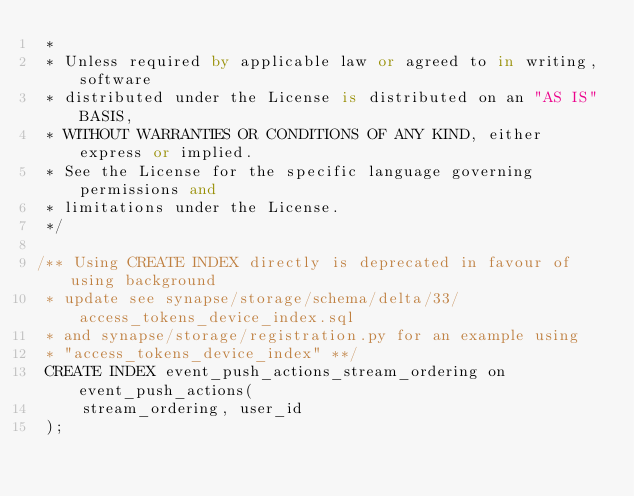<code> <loc_0><loc_0><loc_500><loc_500><_SQL_> *
 * Unless required by applicable law or agreed to in writing, software
 * distributed under the License is distributed on an "AS IS" BASIS,
 * WITHOUT WARRANTIES OR CONDITIONS OF ANY KIND, either express or implied.
 * See the License for the specific language governing permissions and
 * limitations under the License.
 */

/** Using CREATE INDEX directly is deprecated in favour of using background
 * update see synapse/storage/schema/delta/33/access_tokens_device_index.sql
 * and synapse/storage/registration.py for an example using
 * "access_tokens_device_index" **/
 CREATE INDEX event_push_actions_stream_ordering on event_push_actions(
     stream_ordering, user_id
 );
</code> 